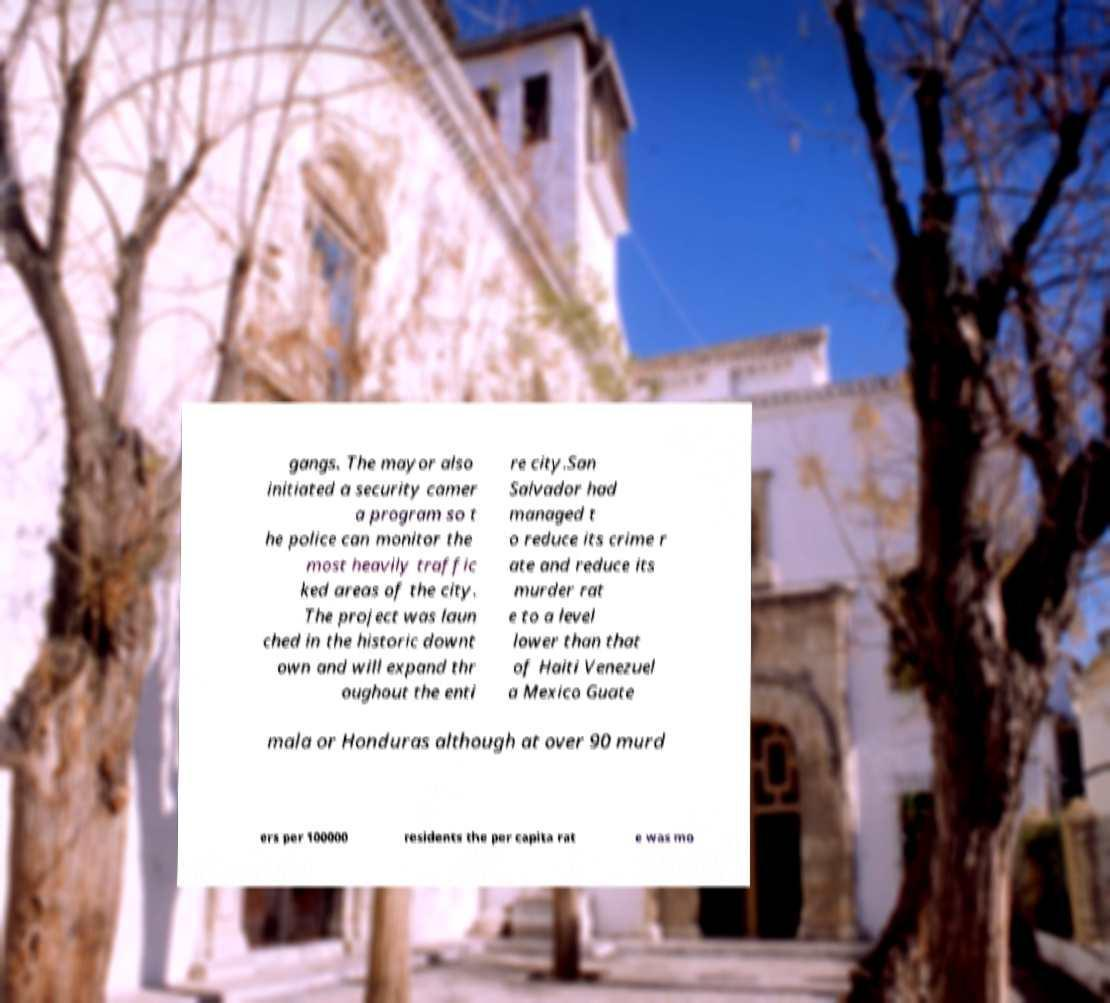Can you accurately transcribe the text from the provided image for me? gangs. The mayor also initiated a security camer a program so t he police can monitor the most heavily traffic ked areas of the city. The project was laun ched in the historic downt own and will expand thr oughout the enti re city.San Salvador had managed t o reduce its crime r ate and reduce its murder rat e to a level lower than that of Haiti Venezuel a Mexico Guate mala or Honduras although at over 90 murd ers per 100000 residents the per capita rat e was mo 